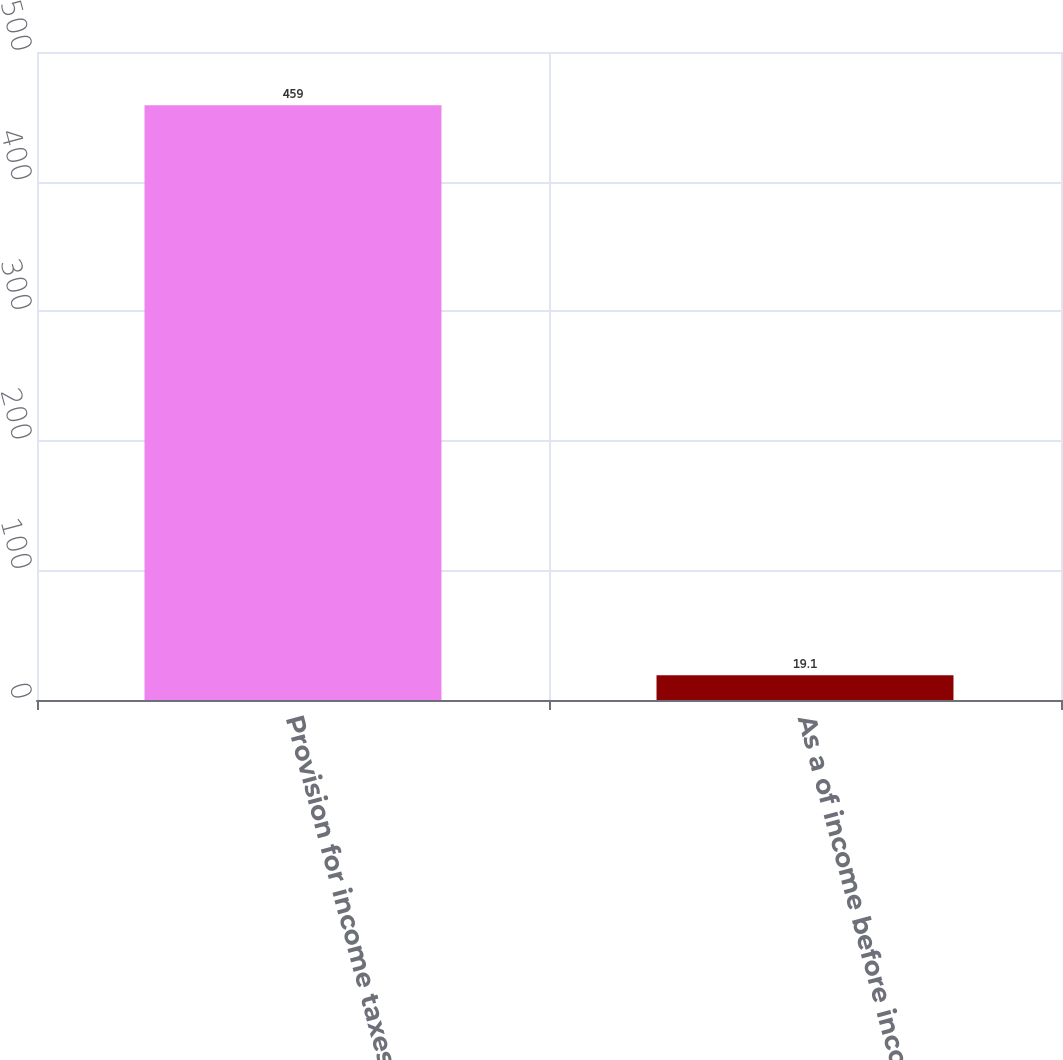Convert chart to OTSL. <chart><loc_0><loc_0><loc_500><loc_500><bar_chart><fcel>Provision for income taxes<fcel>As a of income before income<nl><fcel>459<fcel>19.1<nl></chart> 